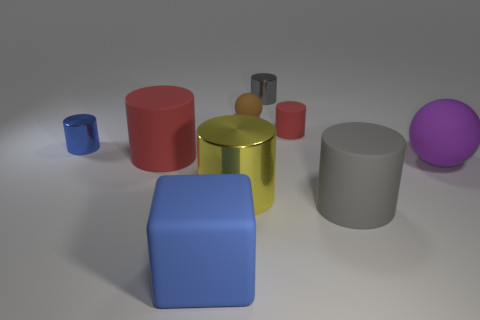How many objects in the image are primarily blue? There are two objects in the image that are primarily blue: a small blue cube and a larger blue cuboid. 